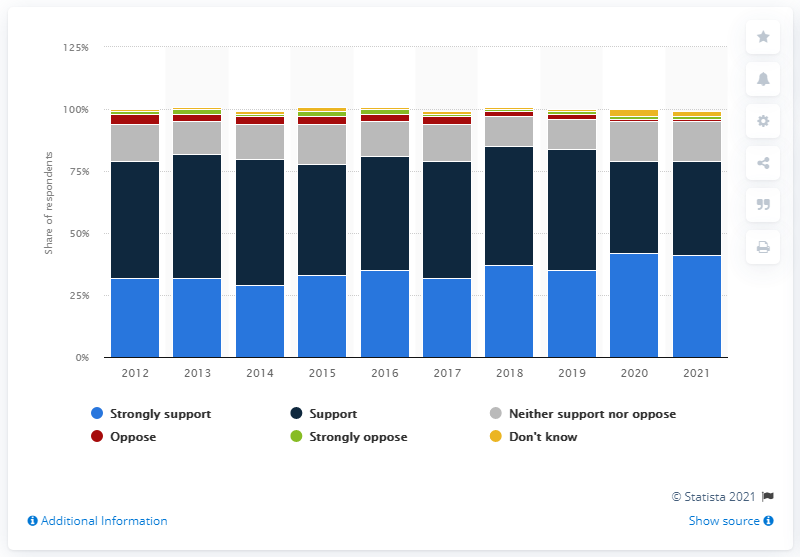Outline some significant characteristics in this image. Since 2012, support for renewable energy in the UK has remained relatively unchanged. 